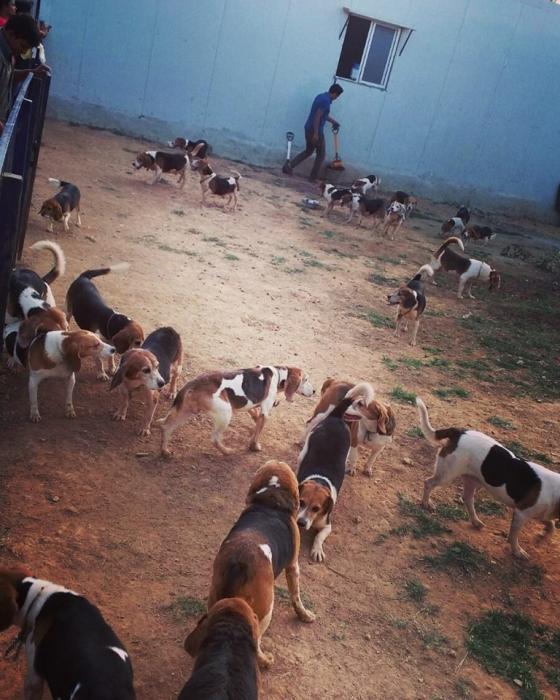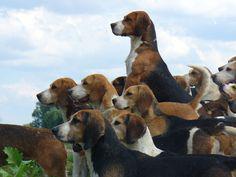The first image is the image on the left, the second image is the image on the right. Given the left and right images, does the statement "Some of the dogs are compacted in a group that are all facing to the immediate left." hold true? Answer yes or no. Yes. 